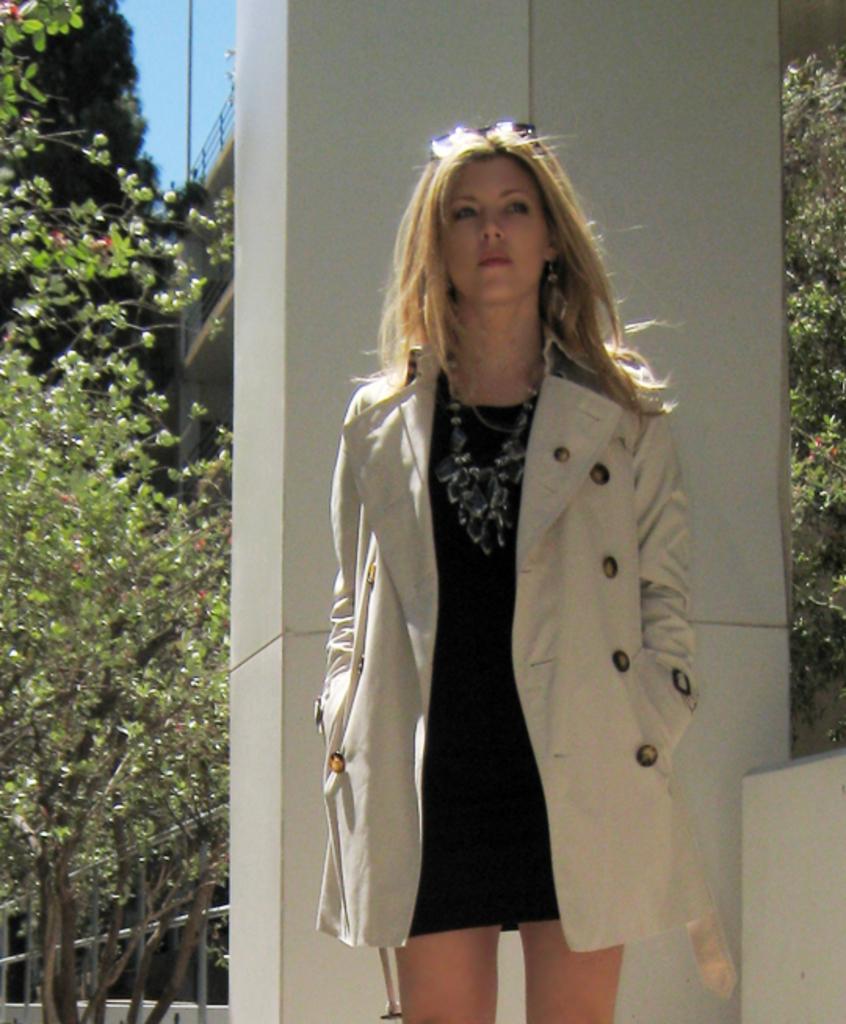Please provide a concise description of this image. In the center of the image we can see a lady is standing and wearing a coat, chain, goggles. In the background of the image we can see a pillar, building, railing, trees, rods, pole. In the top left corner we can see the sky. 